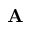<formula> <loc_0><loc_0><loc_500><loc_500>A</formula> 